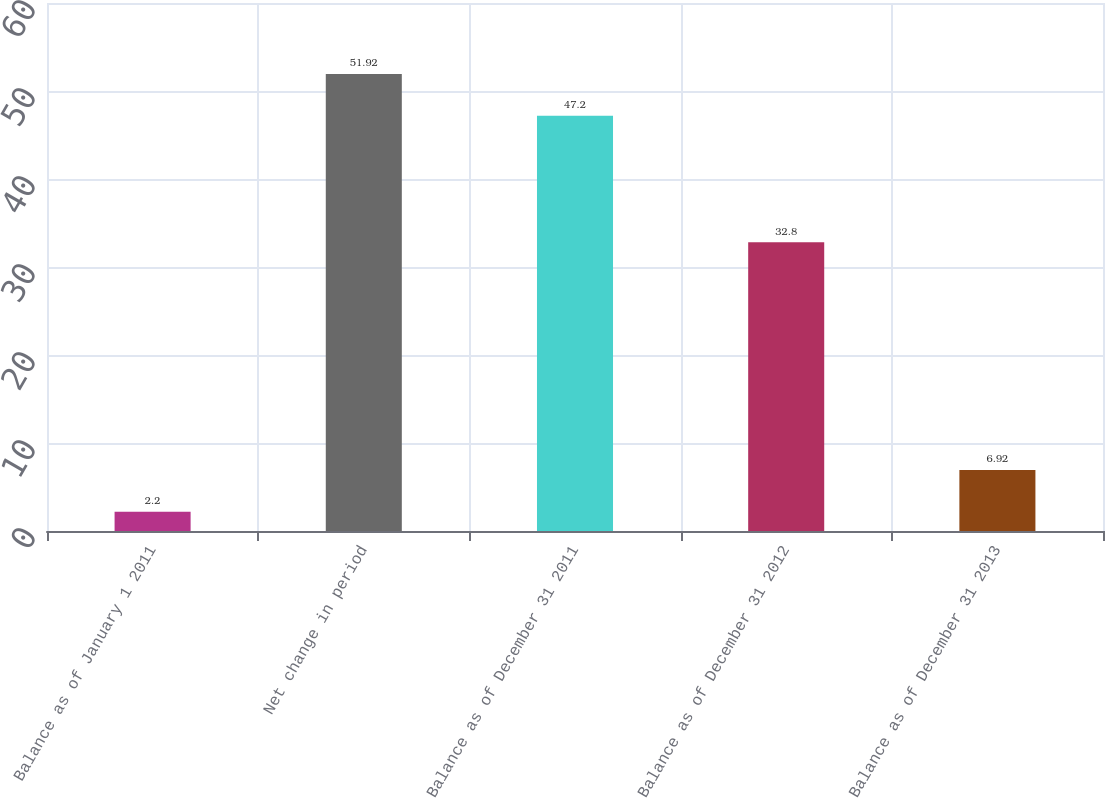Convert chart to OTSL. <chart><loc_0><loc_0><loc_500><loc_500><bar_chart><fcel>Balance as of January 1 2011<fcel>Net change in period<fcel>Balance as of December 31 2011<fcel>Balance as of December 31 2012<fcel>Balance as of December 31 2013<nl><fcel>2.2<fcel>51.92<fcel>47.2<fcel>32.8<fcel>6.92<nl></chart> 